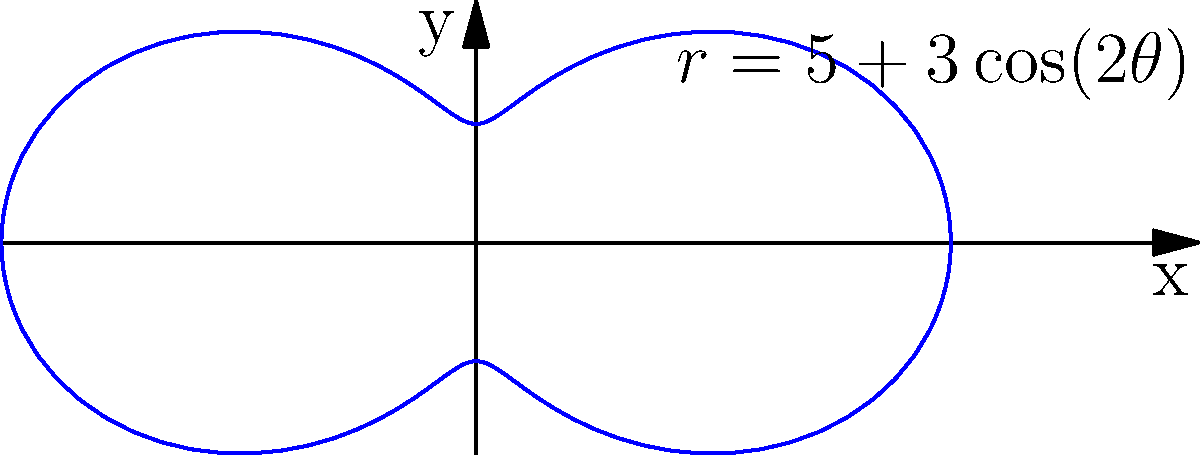As a volunteer at a technology-focused nonprofit, you're working on optimizing wireless network coverage. The signal strength of a transmitter is modeled by the polar equation $r = 5 + 3\cos(2\theta)$, where $r$ represents the signal strength in arbitrary units and $\theta$ is the angle in radians. What is the total area covered by this transmitter, rounded to two decimal places? To find the area covered by the transmitter, we need to calculate the area enclosed by the polar curve. The formula for the area of a region bounded by a polar curve $r = f(\theta)$ from $\theta = a$ to $\theta = b$ is:

$$A = \frac{1}{2} \int_a^b [f(\theta)]^2 d\theta$$

For our case:
1) $f(\theta) = 5 + 3\cos(2\theta)$
2) The curve makes a complete revolution, so $a = 0$ and $b = 2\pi$

Let's solve:

$$\begin{align*}
A &= \frac{1}{2} \int_0^{2\pi} [5 + 3\cos(2\theta)]^2 d\theta \\
&= \frac{1}{2} \int_0^{2\pi} [25 + 30\cos(2\theta) + 9\cos^2(2\theta)] d\theta \\
&= \frac{1}{2} \left[25\theta + 15\sin(2\theta) + \frac{9}{2}\theta + \frac{9}{4}\sin(4\theta)\right]_0^{2\pi} \\
&= \frac{1}{2} \left[(25 + \frac{9}{2})2\pi + 0\right] \\
&= \frac{1}{2} \cdot \frac{59}{2} \cdot 2\pi \\
&= \frac{59\pi}{2} \\
&\approx 92.73
\end{align*}$$

Rounded to two decimal places, the area is 92.73 square units.
Answer: 92.73 square units 